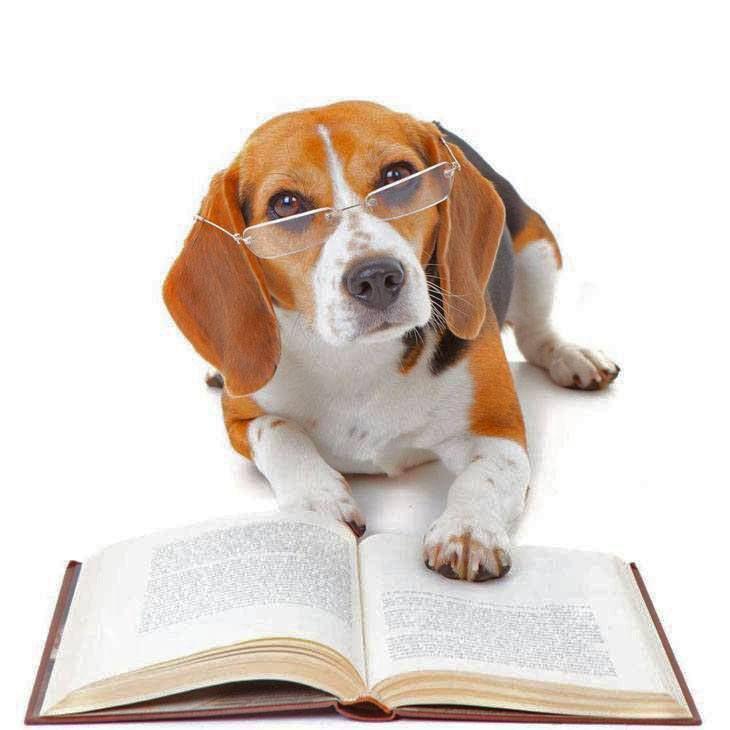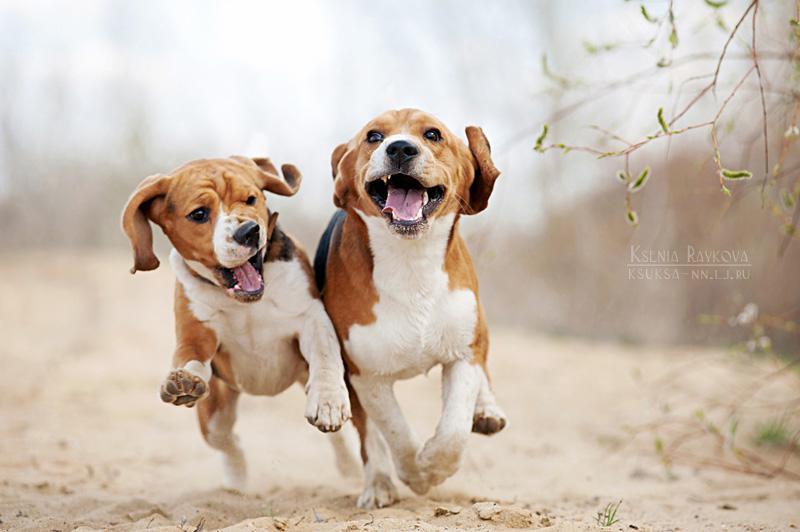The first image is the image on the left, the second image is the image on the right. For the images shown, is this caption "One image shows multiple dogs moving forward, and the other image shows a single camera-facing hound." true? Answer yes or no. Yes. 